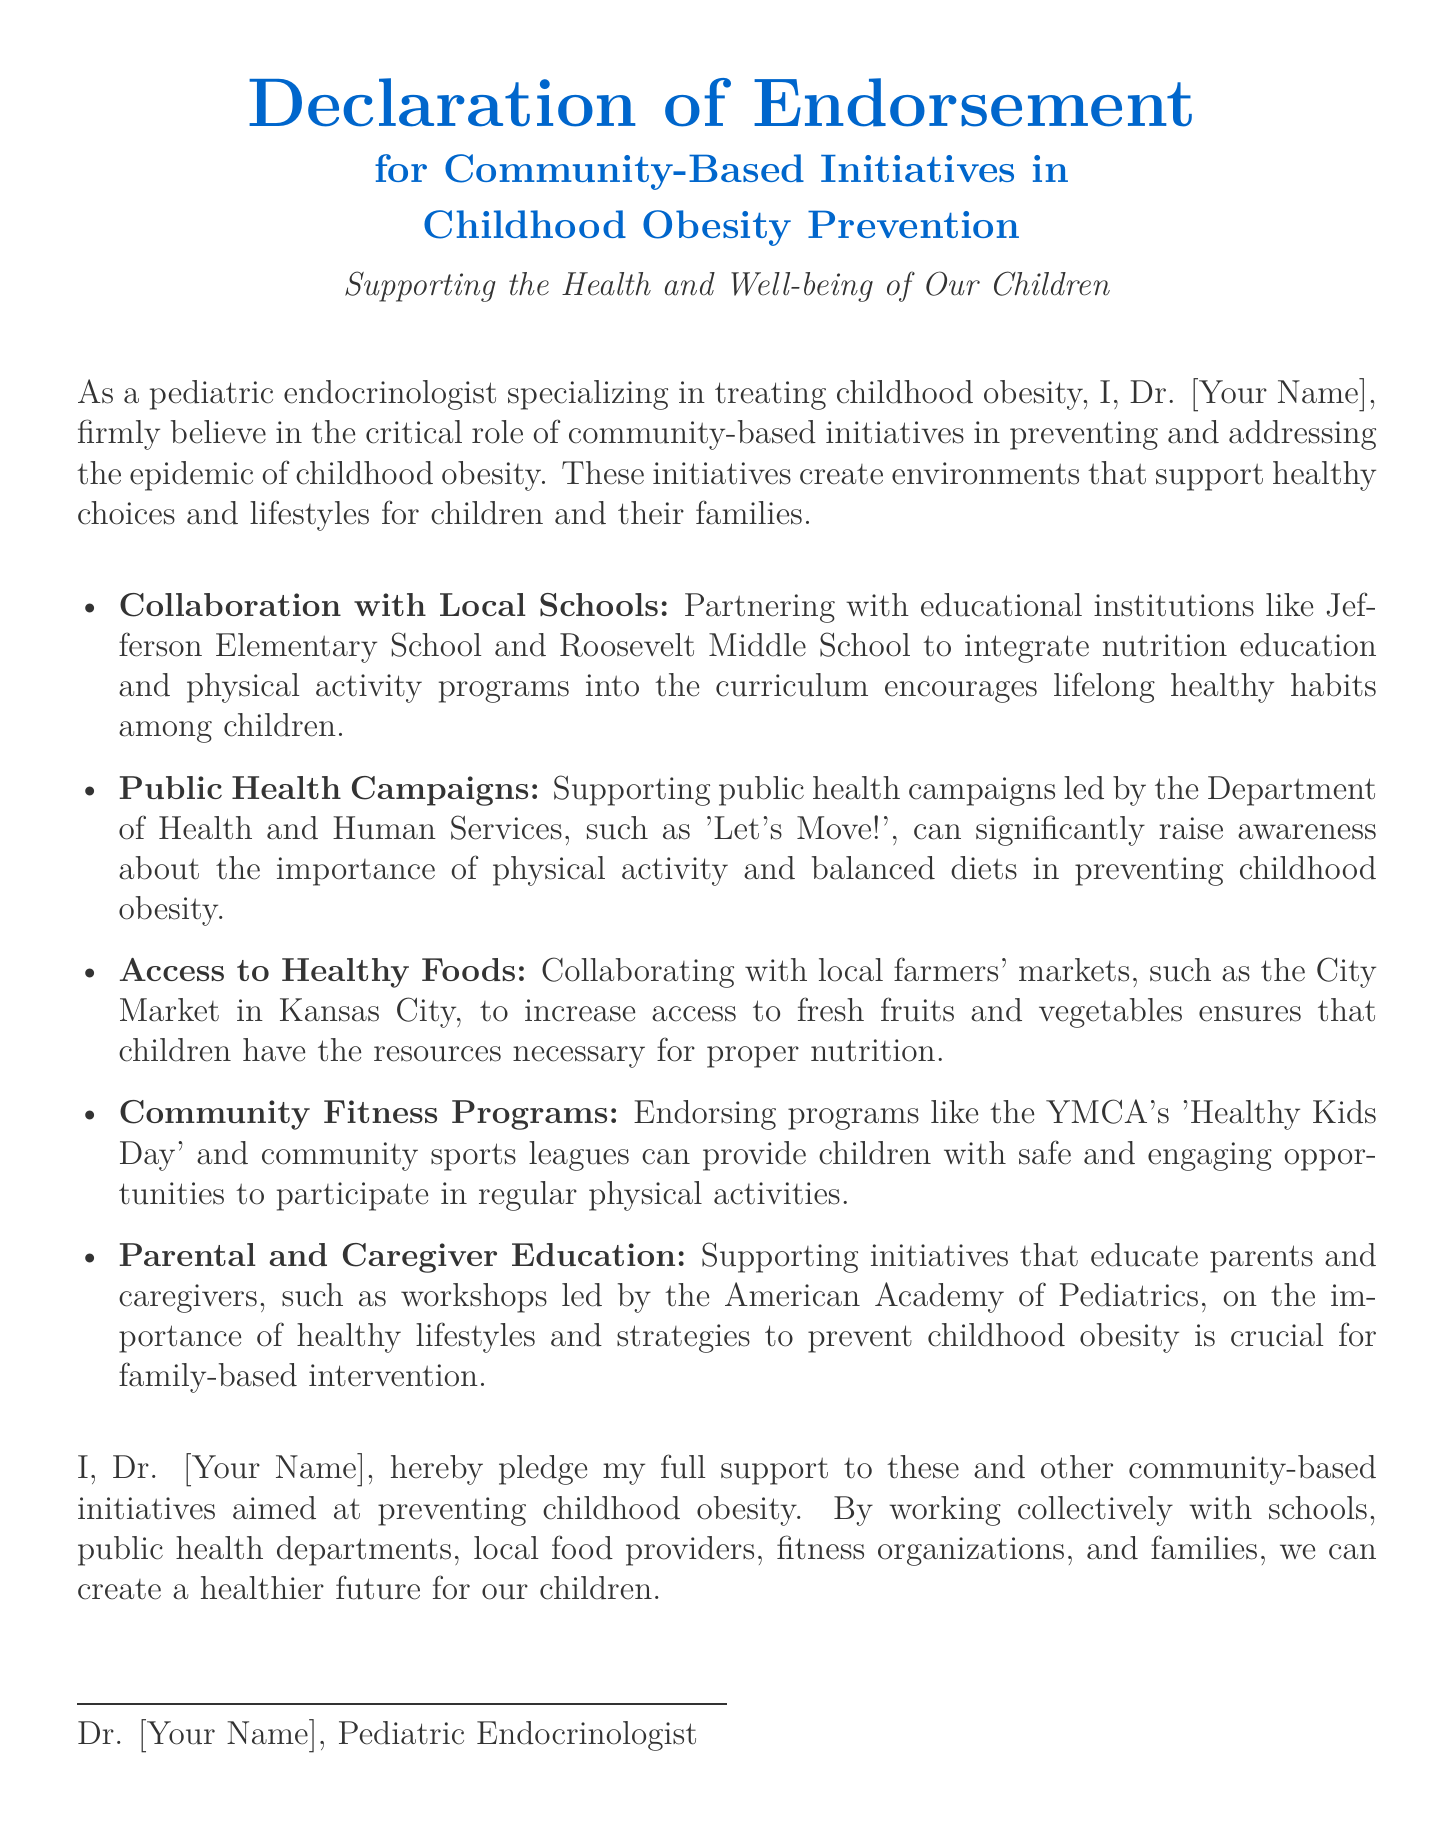What is the title of the document? The title of the document is presented prominently at the beginning, indicating its main focus.
Answer: Declaration of Endorsement for Community-Based Initiatives in Childhood Obesity Prevention Who is the author of the declaration? The document mentions the author who endorses community-based initiatives for childhood obesity prevention.
Answer: Dr. [Your Name] What is one local school mentioned in the document? The document lists specific schools that the author collaborates with as part of community-based initiatives.
Answer: Jefferson Elementary School What public health campaign is supported by the author? The document refers to a specific campaign that promotes physical activity and balanced diets to prevent childhood obesity.
Answer: Let's Move! What is a community fitness program endorsed by the author? The document provides an example of a fitness program that offers opportunities for children to engage in physical activities.
Answer: YMCA's Healthy Kids Day How many bullet points are listed for community initiatives? The document uses a bullet-point list to outline various initiatives, and counting these provides the total number.
Answer: Five What organization leads workshops for parental education mentioned in the document? The document identifies an organization that provides education on healthy lifestyles and preventing childhood obesity for parents and caregivers.
Answer: American Academy of Pediatrics What is the main pledge made by the author in the document? The document concludes with a commitment that reflects the author's support for community initiatives.
Answer: Full support to community-based initiatives aimed at preventing childhood obesity 